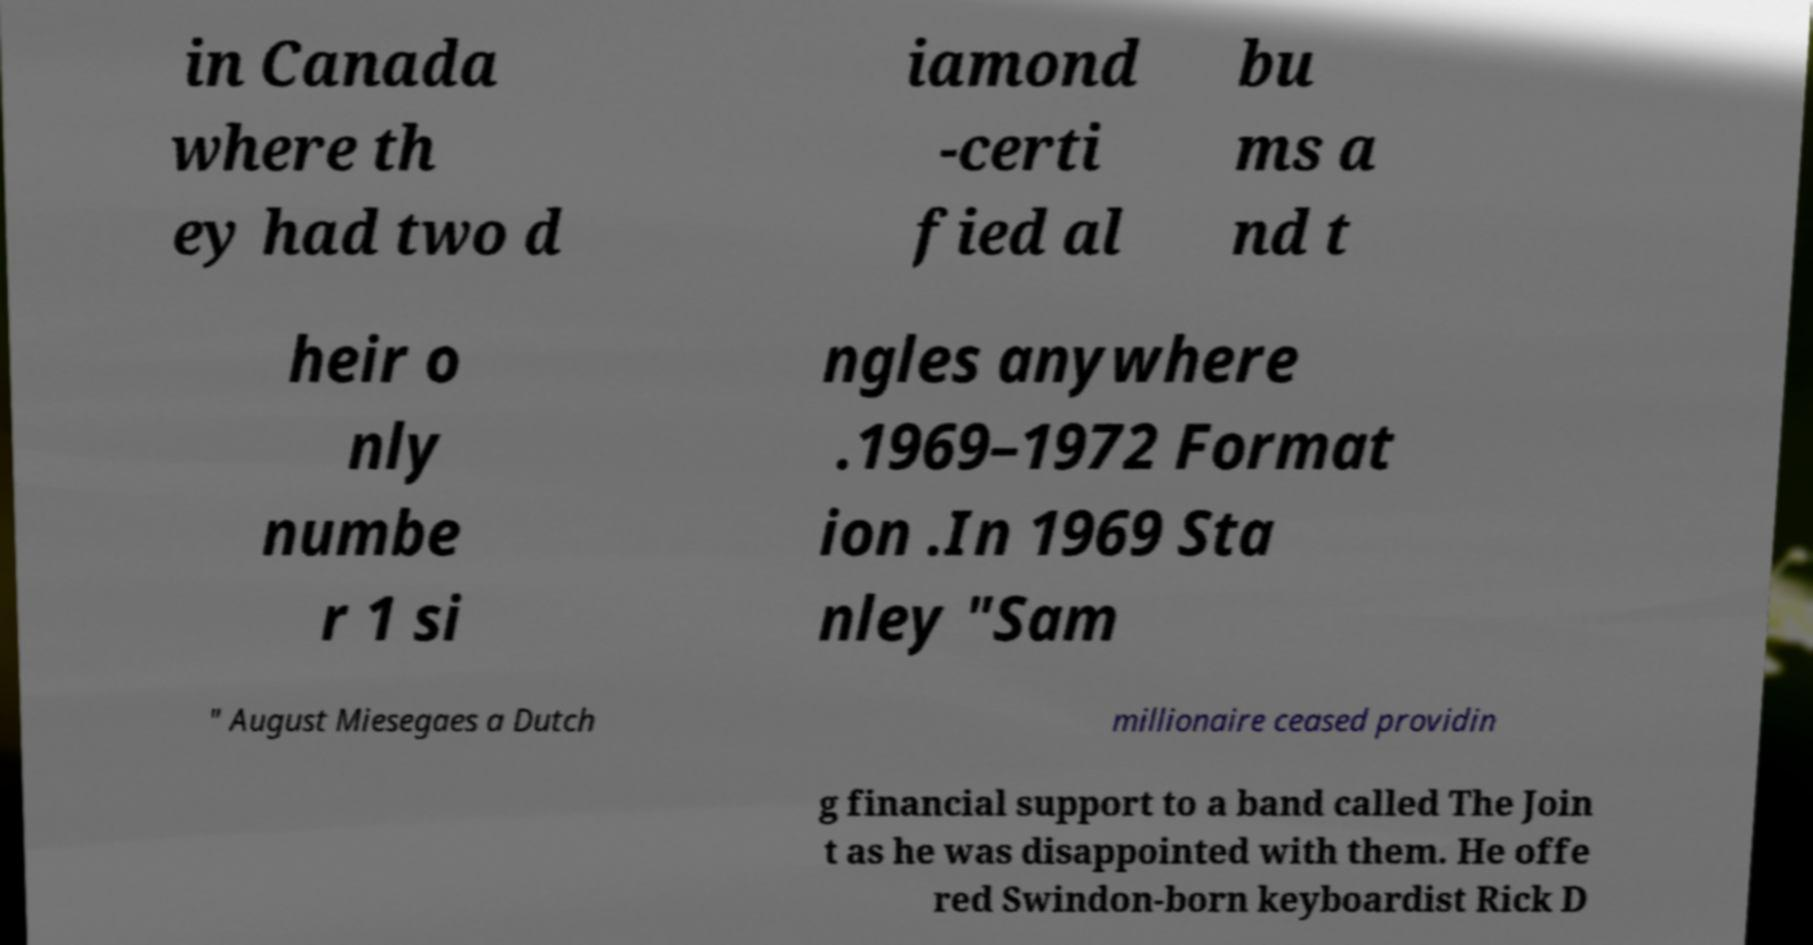I need the written content from this picture converted into text. Can you do that? in Canada where th ey had two d iamond -certi fied al bu ms a nd t heir o nly numbe r 1 si ngles anywhere .1969–1972 Format ion .In 1969 Sta nley "Sam " August Miesegaes a Dutch millionaire ceased providin g financial support to a band called The Join t as he was disappointed with them. He offe red Swindon-born keyboardist Rick D 